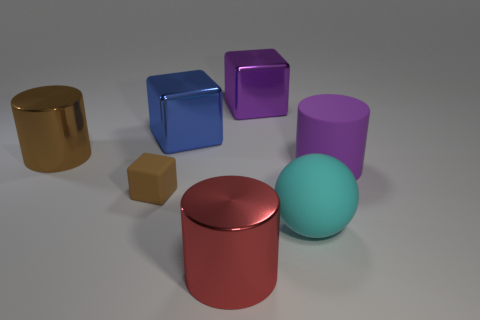How many other things are there of the same color as the tiny rubber cube?
Offer a terse response. 1. Is the number of shiny cubes right of the big purple block less than the number of rubber cubes?
Provide a short and direct response. Yes. What number of large cyan rubber balls are there?
Provide a short and direct response. 1. How many large brown cylinders have the same material as the blue block?
Offer a very short reply. 1. How many objects are big shiny cubes on the right side of the big red metallic cylinder or cylinders?
Provide a short and direct response. 4. Are there fewer small things to the left of the tiny brown object than cylinders left of the cyan rubber sphere?
Keep it short and to the point. Yes. Are there any large metal things right of the big red metal cylinder?
Ensure brevity in your answer.  Yes. How many things are either cylinders in front of the large purple rubber cylinder or things in front of the cyan ball?
Your answer should be compact. 1. How many shiny objects are the same color as the small rubber object?
Give a very brief answer. 1. There is a large rubber thing that is the same shape as the red metal thing; what is its color?
Your response must be concise. Purple. 